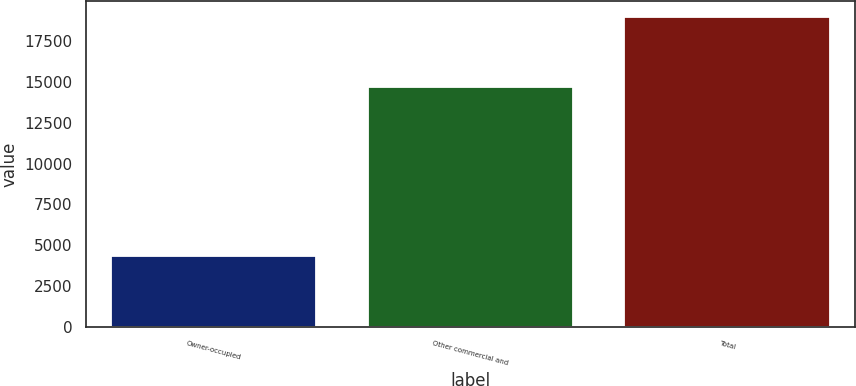Convert chart to OTSL. <chart><loc_0><loc_0><loc_500><loc_500><bar_chart><fcel>Owner-occupied<fcel>Other commercial and<fcel>Total<nl><fcel>4320<fcel>14676<fcel>18996<nl></chart> 